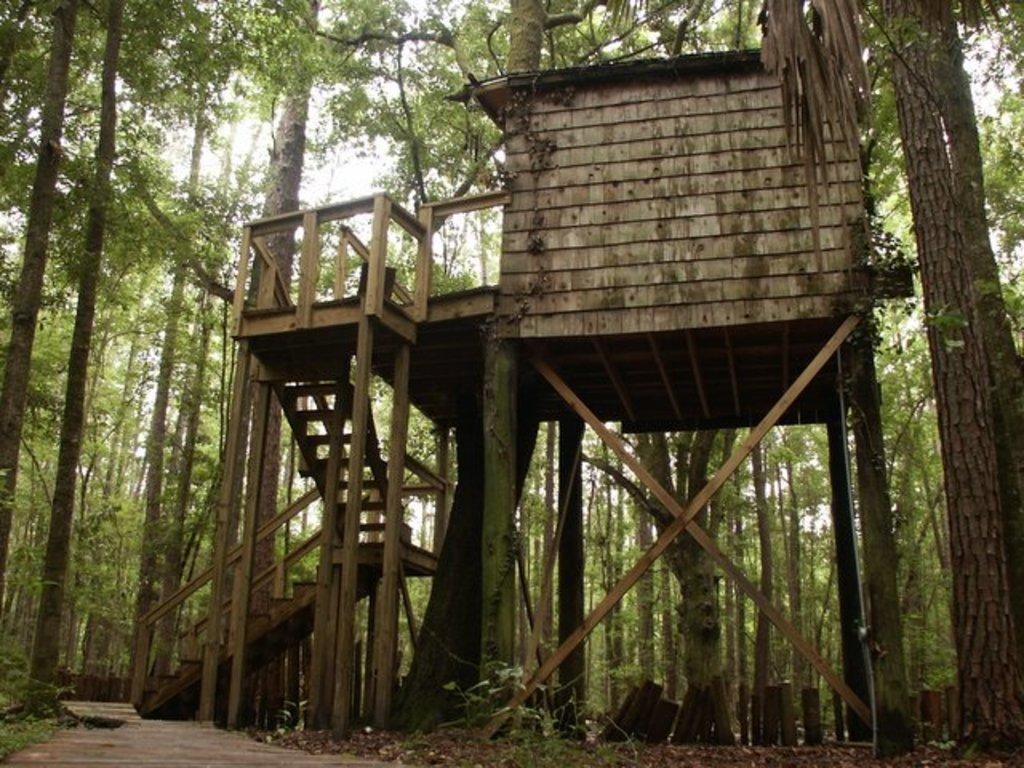What type of structure is present in the image? There is a tree house in the image. How can someone access the tree house? The tree house has wooden stairs. What feature surrounds the tree house? The tree house has a wooden fence. What type of natural environment is visible in the image? There are trees around the tree house. What type of skirt is hanging from the tree house in the image? There is no skirt present in the image; the tree house has a wooden fence. 